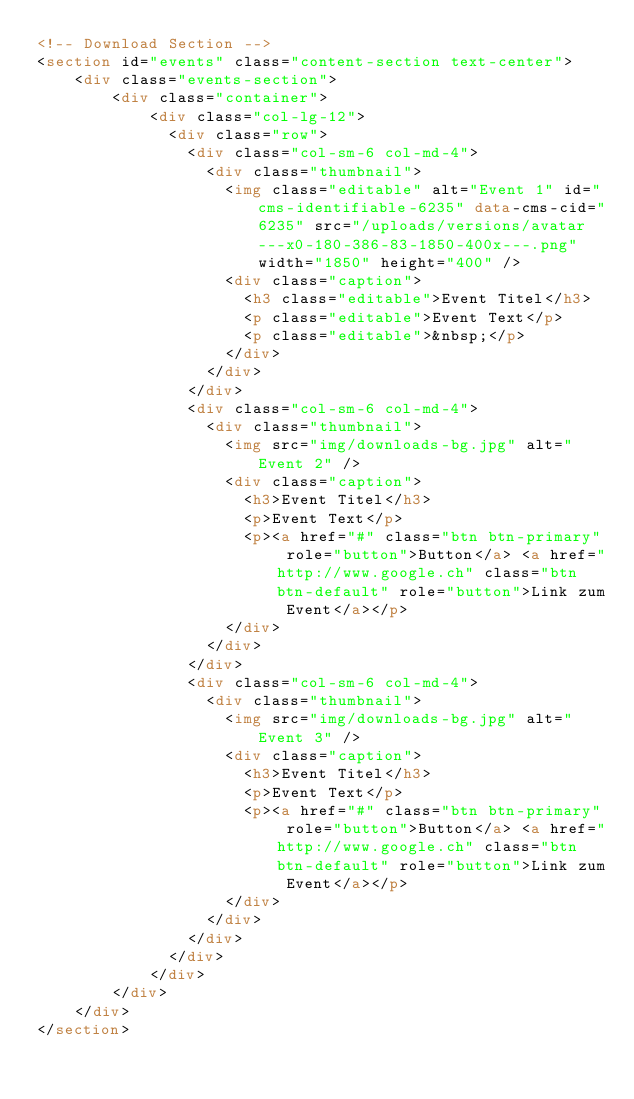Convert code to text. <code><loc_0><loc_0><loc_500><loc_500><_HTML_><!-- Download Section -->
<section id="events" class="content-section text-center">
    <div class="events-section">
        <div class="container">
            <div class="col-lg-12">
              <div class="row">
                <div class="col-sm-6 col-md-4">
                  <div class="thumbnail">
                    <img class="editable" alt="Event 1" id="cms-identifiable-6235" data-cms-cid="6235" src="/uploads/versions/avatar---x0-180-386-83-1850-400x---.png" width="1850" height="400" />
                    <div class="caption">
                      <h3 class="editable">Event Titel</h3>
                      <p class="editable">Event Text</p>
                      <p class="editable">&nbsp;</p>
                    </div>
                  </div>
                </div>
                <div class="col-sm-6 col-md-4">
                  <div class="thumbnail">
                    <img src="img/downloads-bg.jpg" alt="Event 2" />
                    <div class="caption">
                      <h3>Event Titel</h3>
                      <p>Event Text</p>
                      <p><a href="#" class="btn btn-primary" role="button">Button</a> <a href="http://www.google.ch" class="btn btn-default" role="button">Link zum Event</a></p>
                    </div>
                  </div>
                </div>
                <div class="col-sm-6 col-md-4">
                  <div class="thumbnail">
                    <img src="img/downloads-bg.jpg" alt="Event 3" />
                    <div class="caption">
                      <h3>Event Titel</h3>
                      <p>Event Text</p>
                      <p><a href="#" class="btn btn-primary" role="button">Button</a> <a href="http://www.google.ch" class="btn btn-default" role="button">Link zum Event</a></p>
                    </div>
                  </div>
                </div>
              </div>
            </div>
        </div>
    </div>
</section>

</code> 